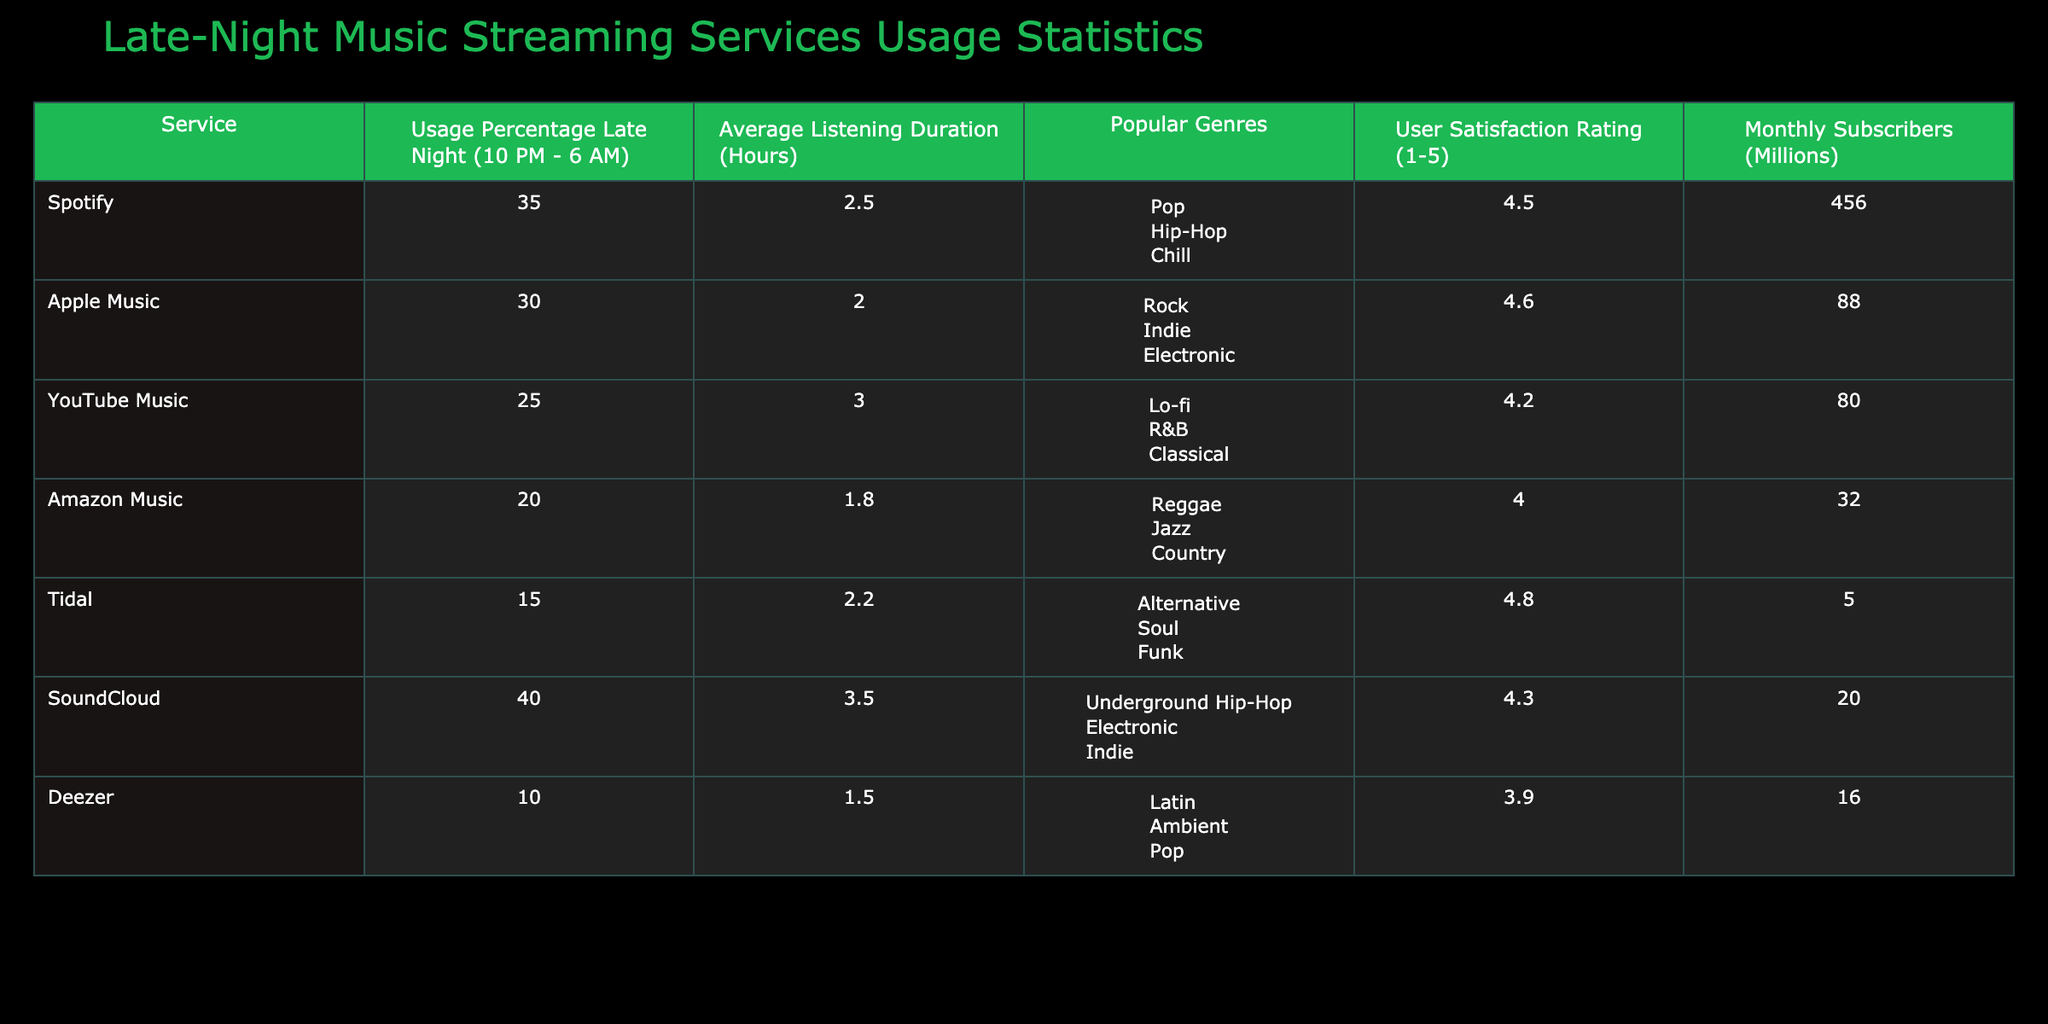What is the user satisfaction rating for Deezer? The table shows the user satisfaction rating for Deezer, which is listed as 3.9.
Answer: 3.9 Which service has the highest usage percentage late at night? By comparing the usage percentages in the table, SoundCloud has the highest percentage at 40%.
Answer: SoundCloud What is the average listening duration across all services? To find the average, sum the listening durations: (2.5 + 2.0 + 3.0 + 1.8 + 2.2 + 3.5 + 1.5) = 16.5 hours. There are 7 services, so the average is 16.5 / 7 ≈ 2.36 hours.
Answer: 2.36 Is the popular genre for Apple Music listed as Electronic? The popular genres for Apple Music are Rock, Indie, and Electronic, confirming that Electronic is indeed one of them.
Answer: Yes What is the difference in the average listening duration between Spotify and Amazon Music? The average listening duration for Spotify is 2.5 hours, and for Amazon Music, it’s 1.8 hours. The difference is 2.5 - 1.8 = 0.7 hours.
Answer: 0.7 hours Which service has the lowest number of monthly subscribers? From the table, Amazon Music has 32 million subscribers, and Tidal has 5 million, which is the lowest.
Answer: Tidal If we combine the usage percentages of Spotify and SoundCloud, what is the total? The usage percentage for Spotify is 35%, and for SoundCloud, it is 40%. The total is 35 + 40 = 75%.
Answer: 75% Is the average user satisfaction rating higher for Tidal compared to YouTube Music? Tidal’s rating is 4.8 and YouTube Music’s is 4.2. Since 4.8 is greater than 4.2, Tidal has a higher rating.
Answer: Yes How many more monthly subscribers does Spotify have compared to Tidal? Spotify has 456 million subscribers, while Tidal has 5 million. The difference is 456 - 5 = 451 million.
Answer: 451 million 